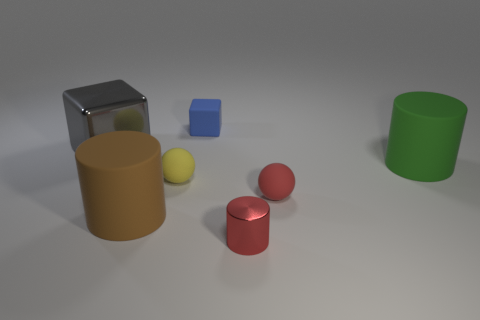Does the green cylinder have the same size as the gray metallic block?
Ensure brevity in your answer.  Yes. Are there more spheres in front of the yellow ball than small purple objects?
Provide a short and direct response. Yes. What size is the gray cube that is made of the same material as the red cylinder?
Your answer should be compact. Large. There is a small rubber block; are there any cubes in front of it?
Ensure brevity in your answer.  Yes. Is the shape of the brown object the same as the tiny red shiny thing?
Offer a terse response. Yes. What is the size of the rubber cylinder left of the block behind the metallic cube that is to the left of the green thing?
Offer a very short reply. Large. What material is the yellow sphere?
Provide a succinct answer. Rubber. Do the blue object and the shiny thing to the left of the red metal thing have the same shape?
Offer a terse response. Yes. What material is the big block on the left side of the rubber sphere to the left of the cylinder in front of the large brown matte object made of?
Your answer should be compact. Metal. What number of big green objects are there?
Keep it short and to the point. 1. 